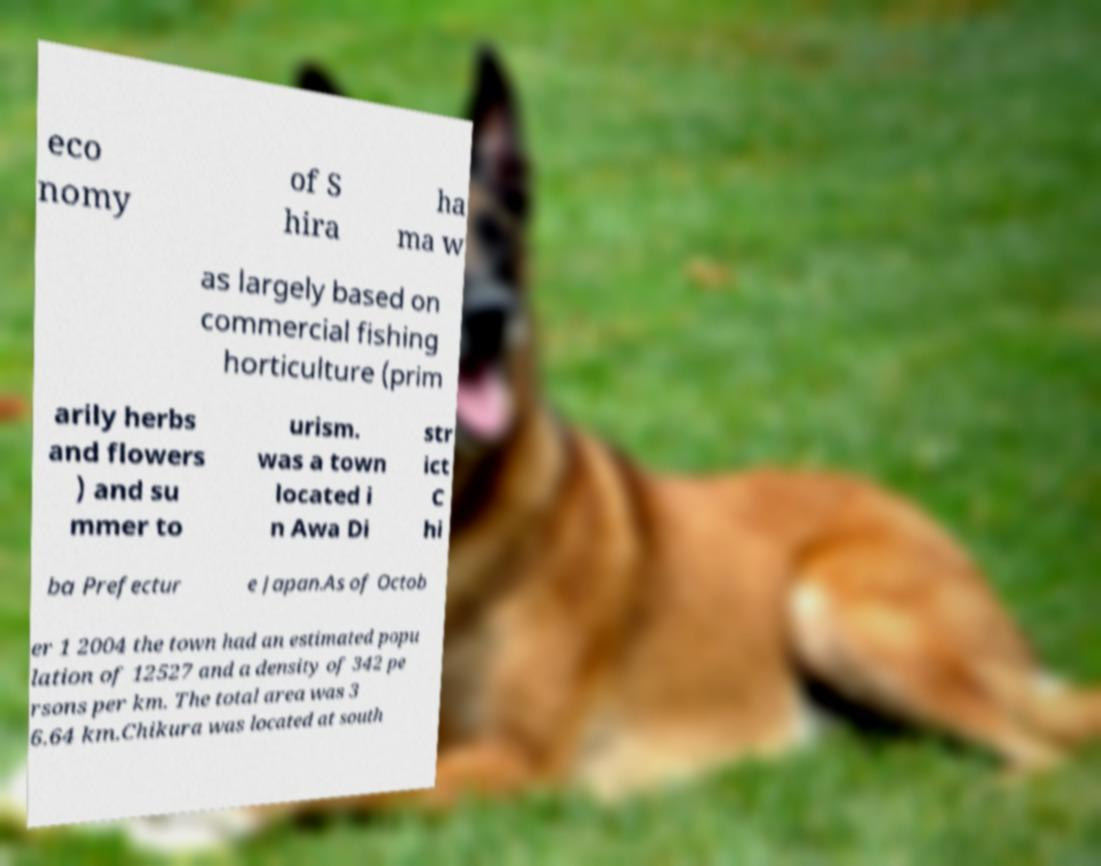Please read and relay the text visible in this image. What does it say? eco nomy of S hira ha ma w as largely based on commercial fishing horticulture (prim arily herbs and flowers ) and su mmer to urism. was a town located i n Awa Di str ict C hi ba Prefectur e Japan.As of Octob er 1 2004 the town had an estimated popu lation of 12527 and a density of 342 pe rsons per km. The total area was 3 6.64 km.Chikura was located at south 